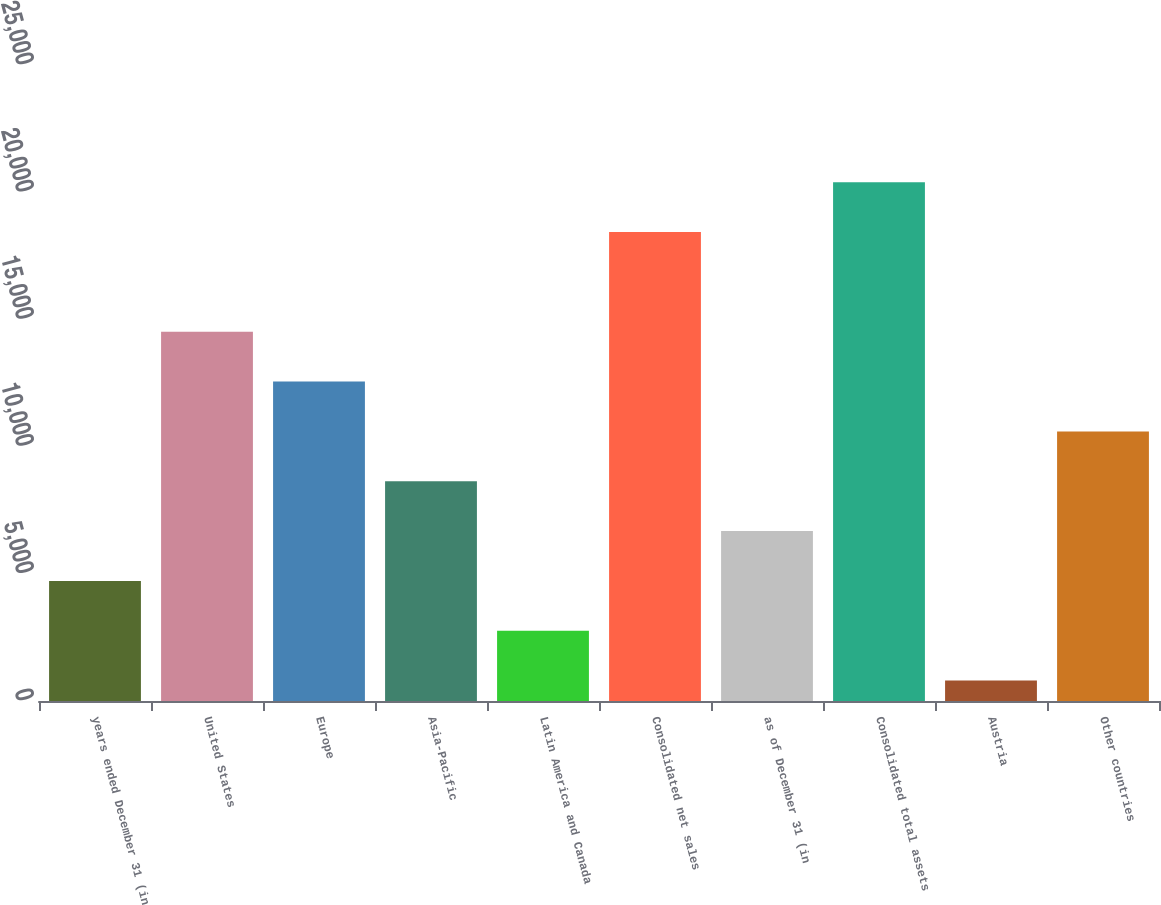<chart> <loc_0><loc_0><loc_500><loc_500><bar_chart><fcel>years ended December 31 (in<fcel>United States<fcel>Europe<fcel>Asia-Pacific<fcel>Latin America and Canada<fcel>Consolidated net sales<fcel>as of December 31 (in<fcel>Consolidated total assets<fcel>Austria<fcel>Other countries<nl><fcel>4719.6<fcel>14513.6<fcel>12554.8<fcel>8637.2<fcel>2760.8<fcel>18431.2<fcel>6678.4<fcel>20390<fcel>802<fcel>10596<nl></chart> 